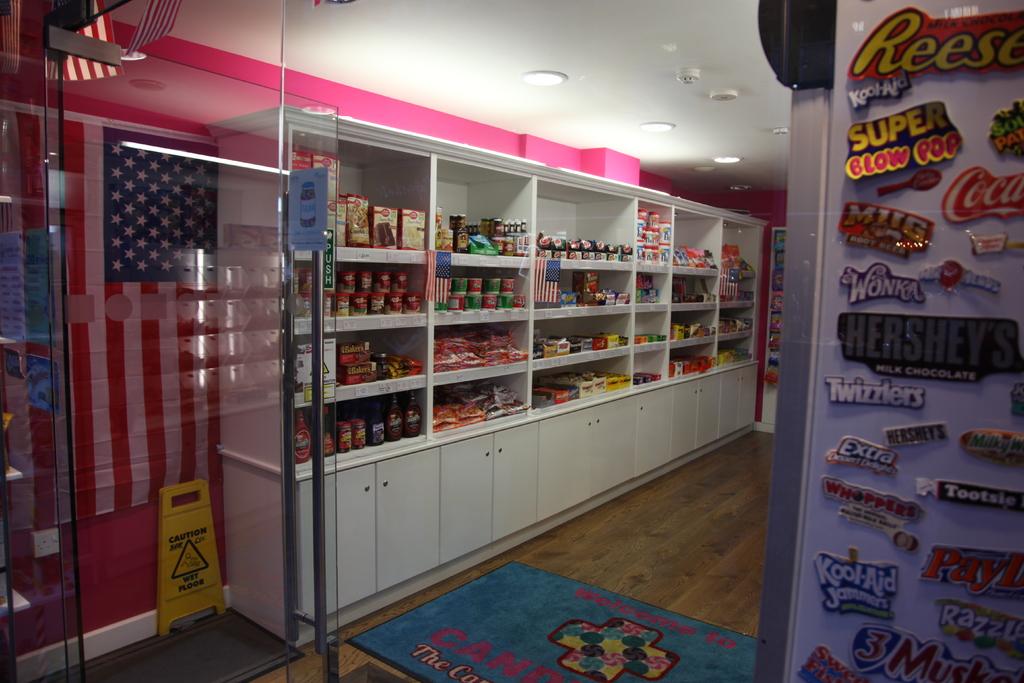What kind of blow pop brand is shown?
Provide a succinct answer. Super. 